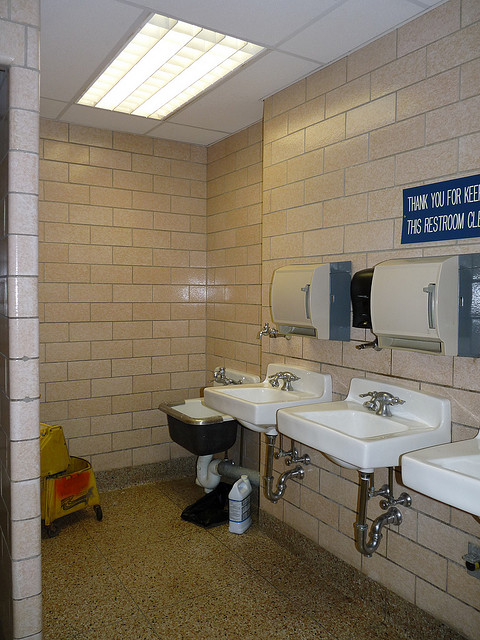What materials are used in the construction of this restroom? The restroom's construction prominently features ceramic sinks, metal fixtures, and tiled walls, typical of public restrooms for durability and ease of cleaning. 